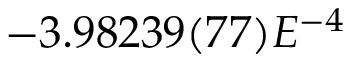<formula> <loc_0><loc_0><loc_500><loc_500>- 3 . 9 8 2 3 9 ( 7 7 ) E ^ { - 4 }</formula> 